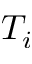Convert formula to latex. <formula><loc_0><loc_0><loc_500><loc_500>T _ { i }</formula> 